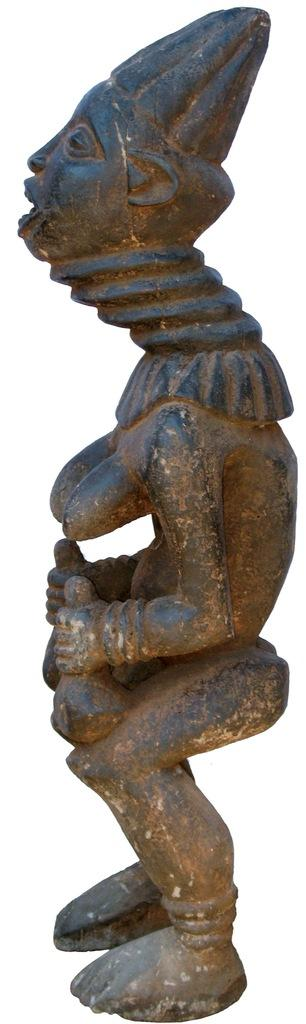What is the main subject in the image? There is a sculpture in the image. Where is the sculpture located in relation to the image? The sculpture is in the front of the image. What color is the background of the image? The background of the image is white. What is the color of the sculpture? The color of the sculpture is brown. What type of reaction does the sculpture have to the design in the image? There is no reaction or design present in the image, as it only features a brown sculpture against a white background. 